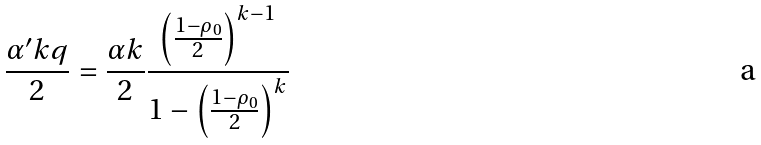<formula> <loc_0><loc_0><loc_500><loc_500>\frac { \alpha ^ { \prime } k q } { 2 } = \frac { \alpha k } 2 \frac { \left ( \frac { 1 - \rho _ { 0 } } 2 \right ) ^ { k - 1 } } { 1 - \left ( \frac { 1 - \rho _ { 0 } } 2 \right ) ^ { k } }</formula> 